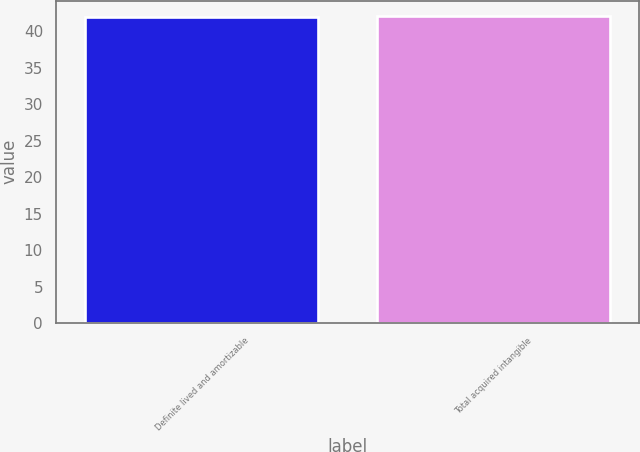Convert chart to OTSL. <chart><loc_0><loc_0><loc_500><loc_500><bar_chart><fcel>Definite lived and amortizable<fcel>Total acquired intangible<nl><fcel>42<fcel>42.1<nl></chart> 